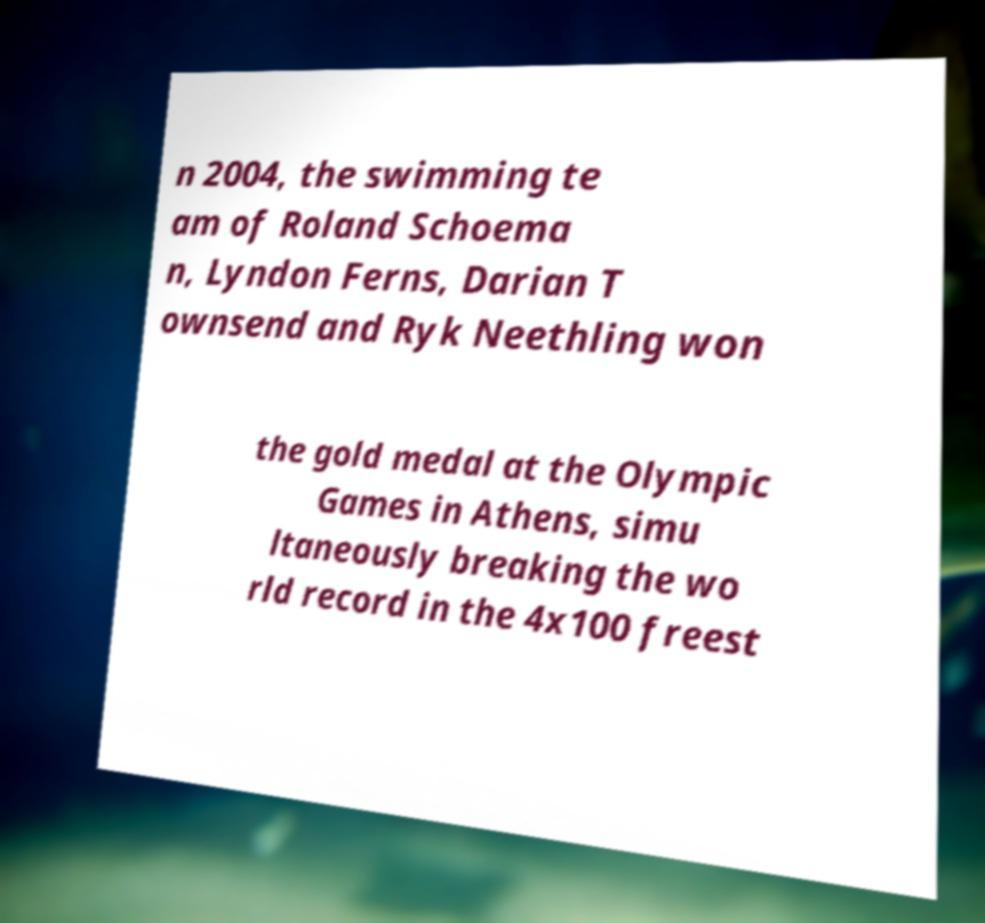I need the written content from this picture converted into text. Can you do that? n 2004, the swimming te am of Roland Schoema n, Lyndon Ferns, Darian T ownsend and Ryk Neethling won the gold medal at the Olympic Games in Athens, simu ltaneously breaking the wo rld record in the 4x100 freest 